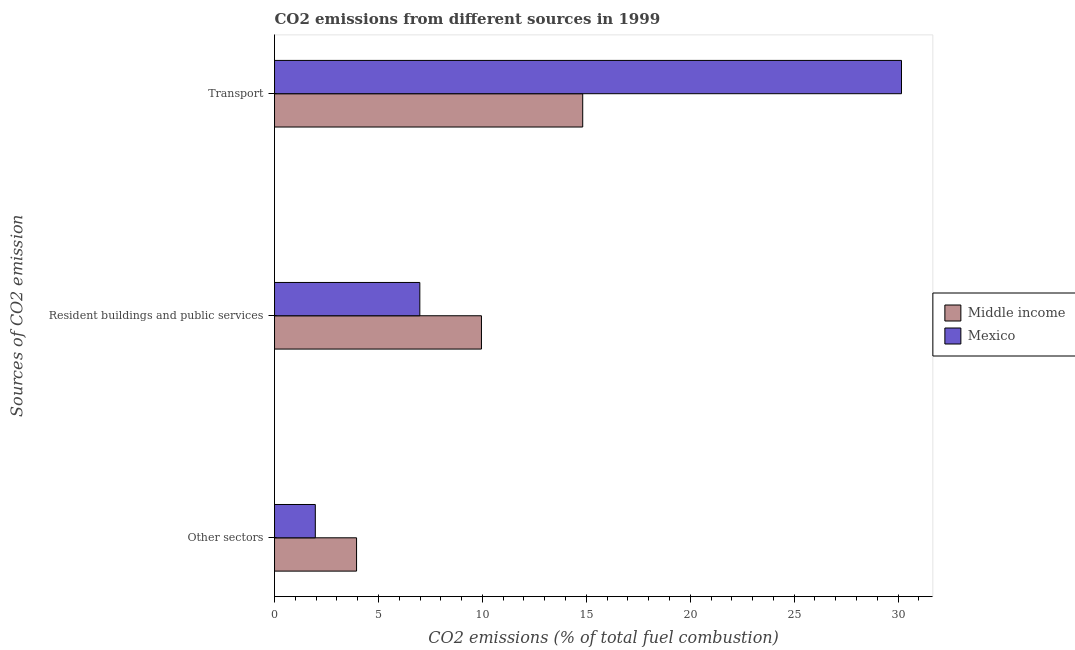How many different coloured bars are there?
Keep it short and to the point. 2. How many groups of bars are there?
Give a very brief answer. 3. Are the number of bars per tick equal to the number of legend labels?
Your answer should be very brief. Yes. Are the number of bars on each tick of the Y-axis equal?
Offer a very short reply. Yes. How many bars are there on the 1st tick from the top?
Provide a short and direct response. 2. How many bars are there on the 3rd tick from the bottom?
Keep it short and to the point. 2. What is the label of the 1st group of bars from the top?
Make the answer very short. Transport. What is the percentage of co2 emissions from resident buildings and public services in Mexico?
Your answer should be very brief. 6.99. Across all countries, what is the maximum percentage of co2 emissions from other sectors?
Provide a short and direct response. 3.95. Across all countries, what is the minimum percentage of co2 emissions from other sectors?
Provide a short and direct response. 1.96. In which country was the percentage of co2 emissions from resident buildings and public services maximum?
Keep it short and to the point. Middle income. In which country was the percentage of co2 emissions from transport minimum?
Your response must be concise. Middle income. What is the total percentage of co2 emissions from other sectors in the graph?
Give a very brief answer. 5.91. What is the difference between the percentage of co2 emissions from transport in Middle income and that in Mexico?
Ensure brevity in your answer.  -15.34. What is the difference between the percentage of co2 emissions from resident buildings and public services in Middle income and the percentage of co2 emissions from transport in Mexico?
Provide a succinct answer. -20.21. What is the average percentage of co2 emissions from transport per country?
Offer a very short reply. 22.49. What is the difference between the percentage of co2 emissions from other sectors and percentage of co2 emissions from transport in Mexico?
Your response must be concise. -28.2. What is the ratio of the percentage of co2 emissions from other sectors in Mexico to that in Middle income?
Give a very brief answer. 0.5. What is the difference between the highest and the second highest percentage of co2 emissions from transport?
Offer a very short reply. 15.34. What is the difference between the highest and the lowest percentage of co2 emissions from resident buildings and public services?
Provide a succinct answer. 2.96. What does the 1st bar from the top in Transport represents?
Offer a terse response. Mexico. What does the 2nd bar from the bottom in Transport represents?
Provide a short and direct response. Mexico. Is it the case that in every country, the sum of the percentage of co2 emissions from other sectors and percentage of co2 emissions from resident buildings and public services is greater than the percentage of co2 emissions from transport?
Give a very brief answer. No. Are all the bars in the graph horizontal?
Ensure brevity in your answer.  Yes. How many countries are there in the graph?
Your response must be concise. 2. What is the difference between two consecutive major ticks on the X-axis?
Your answer should be compact. 5. Are the values on the major ticks of X-axis written in scientific E-notation?
Offer a very short reply. No. Does the graph contain grids?
Make the answer very short. No. Where does the legend appear in the graph?
Ensure brevity in your answer.  Center right. How are the legend labels stacked?
Make the answer very short. Vertical. What is the title of the graph?
Give a very brief answer. CO2 emissions from different sources in 1999. What is the label or title of the X-axis?
Give a very brief answer. CO2 emissions (% of total fuel combustion). What is the label or title of the Y-axis?
Keep it short and to the point. Sources of CO2 emission. What is the CO2 emissions (% of total fuel combustion) in Middle income in Other sectors?
Provide a succinct answer. 3.95. What is the CO2 emissions (% of total fuel combustion) of Mexico in Other sectors?
Make the answer very short. 1.96. What is the CO2 emissions (% of total fuel combustion) in Middle income in Resident buildings and public services?
Your answer should be compact. 9.95. What is the CO2 emissions (% of total fuel combustion) of Mexico in Resident buildings and public services?
Provide a succinct answer. 6.99. What is the CO2 emissions (% of total fuel combustion) in Middle income in Transport?
Offer a terse response. 14.83. What is the CO2 emissions (% of total fuel combustion) of Mexico in Transport?
Your response must be concise. 30.16. Across all Sources of CO2 emission, what is the maximum CO2 emissions (% of total fuel combustion) of Middle income?
Keep it short and to the point. 14.83. Across all Sources of CO2 emission, what is the maximum CO2 emissions (% of total fuel combustion) in Mexico?
Provide a short and direct response. 30.16. Across all Sources of CO2 emission, what is the minimum CO2 emissions (% of total fuel combustion) in Middle income?
Offer a very short reply. 3.95. Across all Sources of CO2 emission, what is the minimum CO2 emissions (% of total fuel combustion) of Mexico?
Your answer should be very brief. 1.96. What is the total CO2 emissions (% of total fuel combustion) in Middle income in the graph?
Provide a short and direct response. 28.73. What is the total CO2 emissions (% of total fuel combustion) in Mexico in the graph?
Your answer should be compact. 39.12. What is the difference between the CO2 emissions (% of total fuel combustion) of Middle income in Other sectors and that in Resident buildings and public services?
Provide a short and direct response. -6.01. What is the difference between the CO2 emissions (% of total fuel combustion) in Mexico in Other sectors and that in Resident buildings and public services?
Your response must be concise. -5.03. What is the difference between the CO2 emissions (% of total fuel combustion) in Middle income in Other sectors and that in Transport?
Your response must be concise. -10.88. What is the difference between the CO2 emissions (% of total fuel combustion) of Mexico in Other sectors and that in Transport?
Offer a terse response. -28.2. What is the difference between the CO2 emissions (% of total fuel combustion) in Middle income in Resident buildings and public services and that in Transport?
Make the answer very short. -4.87. What is the difference between the CO2 emissions (% of total fuel combustion) in Mexico in Resident buildings and public services and that in Transport?
Offer a terse response. -23.17. What is the difference between the CO2 emissions (% of total fuel combustion) of Middle income in Other sectors and the CO2 emissions (% of total fuel combustion) of Mexico in Resident buildings and public services?
Give a very brief answer. -3.04. What is the difference between the CO2 emissions (% of total fuel combustion) in Middle income in Other sectors and the CO2 emissions (% of total fuel combustion) in Mexico in Transport?
Your answer should be very brief. -26.22. What is the difference between the CO2 emissions (% of total fuel combustion) of Middle income in Resident buildings and public services and the CO2 emissions (% of total fuel combustion) of Mexico in Transport?
Ensure brevity in your answer.  -20.21. What is the average CO2 emissions (% of total fuel combustion) of Middle income per Sources of CO2 emission?
Ensure brevity in your answer.  9.58. What is the average CO2 emissions (% of total fuel combustion) in Mexico per Sources of CO2 emission?
Offer a very short reply. 13.04. What is the difference between the CO2 emissions (% of total fuel combustion) in Middle income and CO2 emissions (% of total fuel combustion) in Mexico in Other sectors?
Your answer should be very brief. 1.98. What is the difference between the CO2 emissions (% of total fuel combustion) of Middle income and CO2 emissions (% of total fuel combustion) of Mexico in Resident buildings and public services?
Give a very brief answer. 2.96. What is the difference between the CO2 emissions (% of total fuel combustion) in Middle income and CO2 emissions (% of total fuel combustion) in Mexico in Transport?
Your answer should be very brief. -15.34. What is the ratio of the CO2 emissions (% of total fuel combustion) in Middle income in Other sectors to that in Resident buildings and public services?
Offer a terse response. 0.4. What is the ratio of the CO2 emissions (% of total fuel combustion) in Mexico in Other sectors to that in Resident buildings and public services?
Your answer should be very brief. 0.28. What is the ratio of the CO2 emissions (% of total fuel combustion) in Middle income in Other sectors to that in Transport?
Give a very brief answer. 0.27. What is the ratio of the CO2 emissions (% of total fuel combustion) of Mexico in Other sectors to that in Transport?
Provide a short and direct response. 0.07. What is the ratio of the CO2 emissions (% of total fuel combustion) in Middle income in Resident buildings and public services to that in Transport?
Make the answer very short. 0.67. What is the ratio of the CO2 emissions (% of total fuel combustion) in Mexico in Resident buildings and public services to that in Transport?
Offer a terse response. 0.23. What is the difference between the highest and the second highest CO2 emissions (% of total fuel combustion) in Middle income?
Provide a succinct answer. 4.87. What is the difference between the highest and the second highest CO2 emissions (% of total fuel combustion) in Mexico?
Offer a terse response. 23.17. What is the difference between the highest and the lowest CO2 emissions (% of total fuel combustion) in Middle income?
Provide a succinct answer. 10.88. What is the difference between the highest and the lowest CO2 emissions (% of total fuel combustion) in Mexico?
Keep it short and to the point. 28.2. 